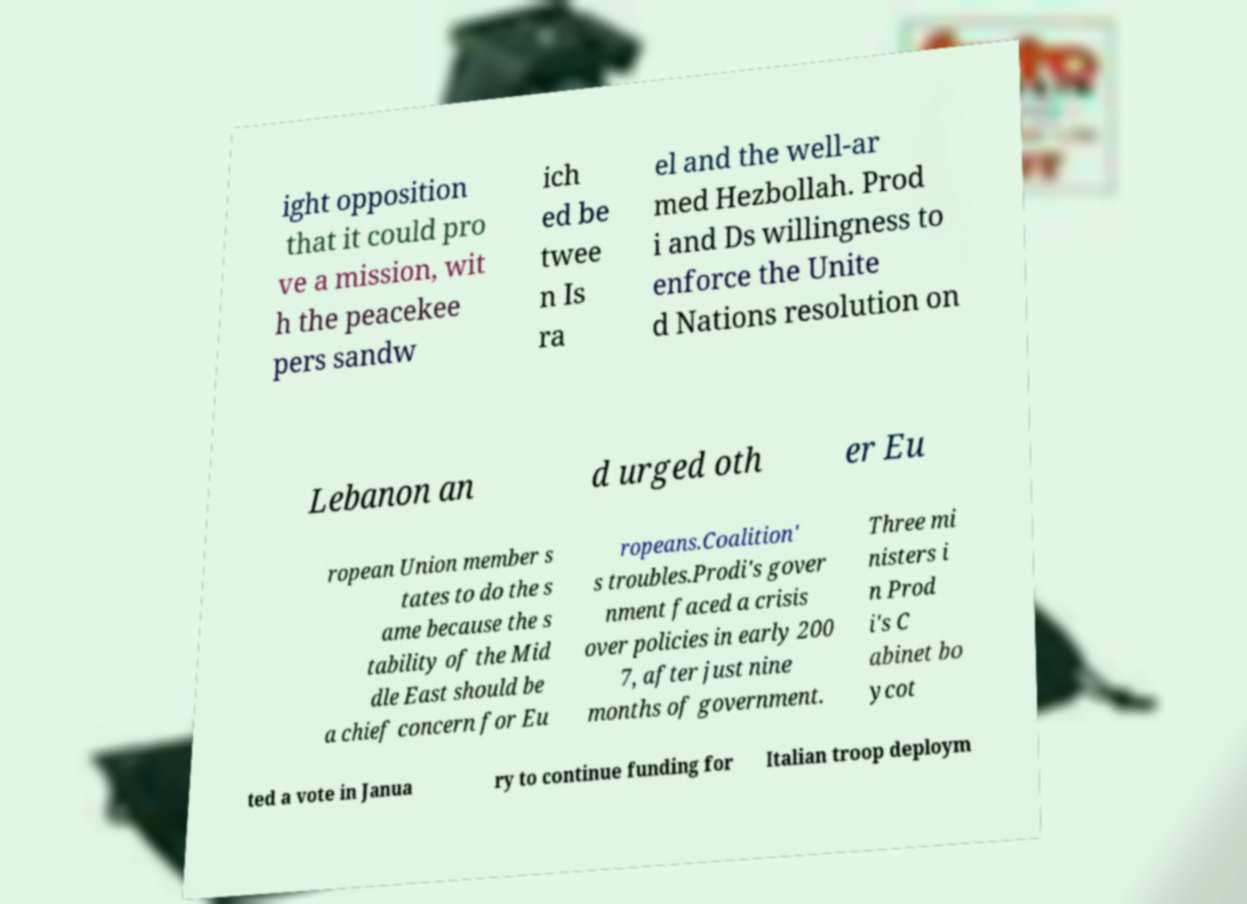Can you accurately transcribe the text from the provided image for me? ight opposition that it could pro ve a mission, wit h the peacekee pers sandw ich ed be twee n Is ra el and the well-ar med Hezbollah. Prod i and Ds willingness to enforce the Unite d Nations resolution on Lebanon an d urged oth er Eu ropean Union member s tates to do the s ame because the s tability of the Mid dle East should be a chief concern for Eu ropeans.Coalition' s troubles.Prodi's gover nment faced a crisis over policies in early 200 7, after just nine months of government. Three mi nisters i n Prod i's C abinet bo ycot ted a vote in Janua ry to continue funding for Italian troop deploym 